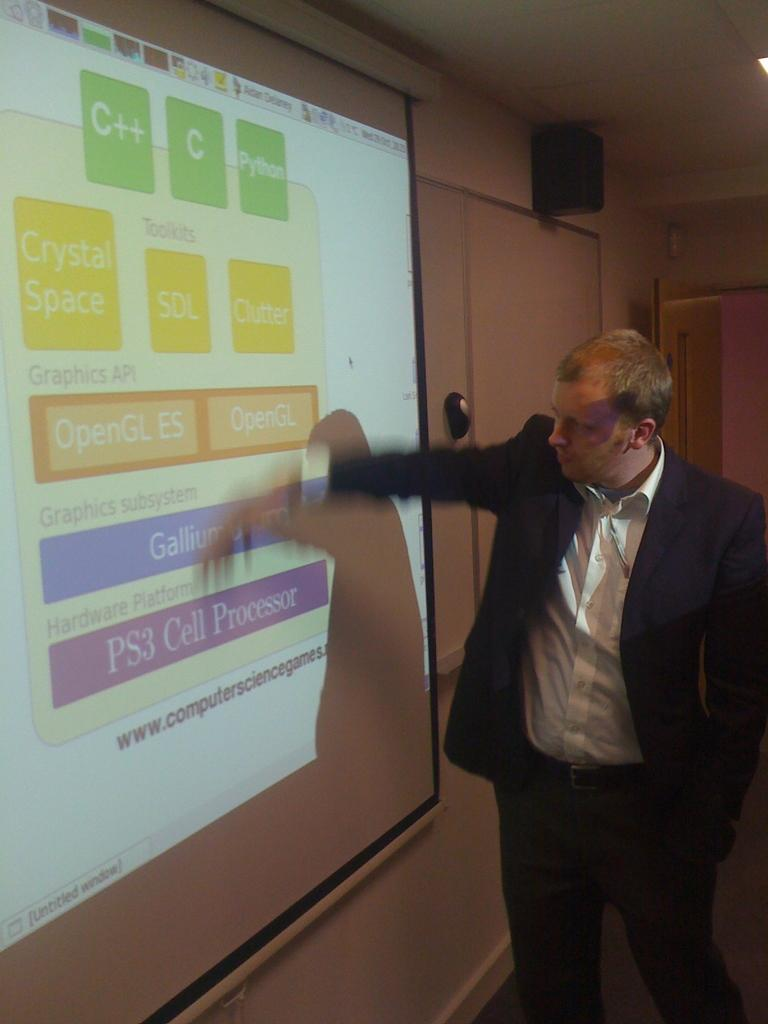<image>
Write a terse but informative summary of the picture. A man explains a slide about the PS3 Cell Processor 